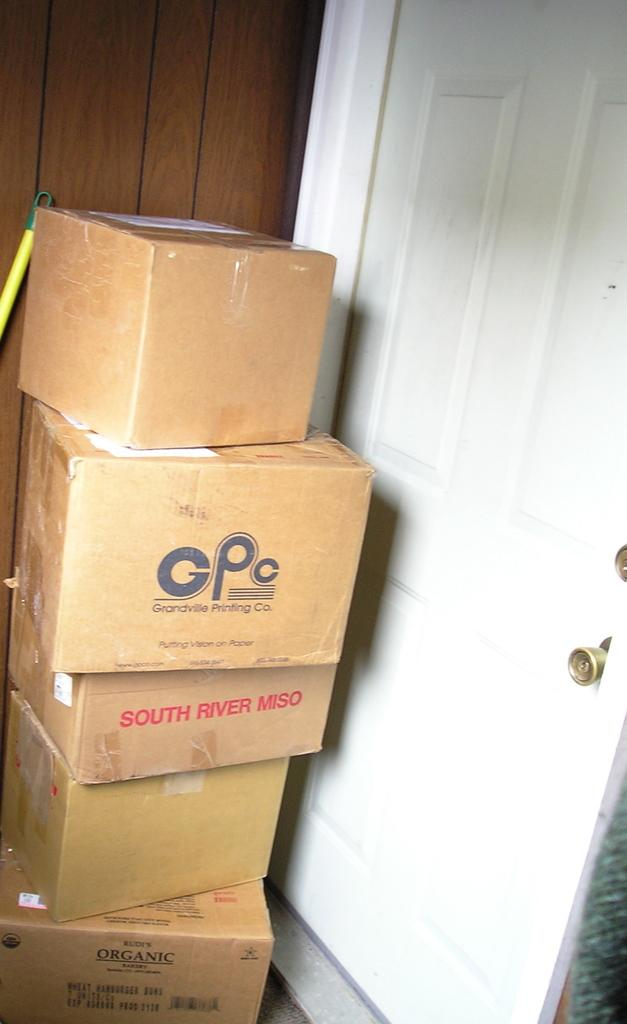Provide a one-sentence caption for the provided image. Boxes stacked on each other and one of them is labeled GPC. 